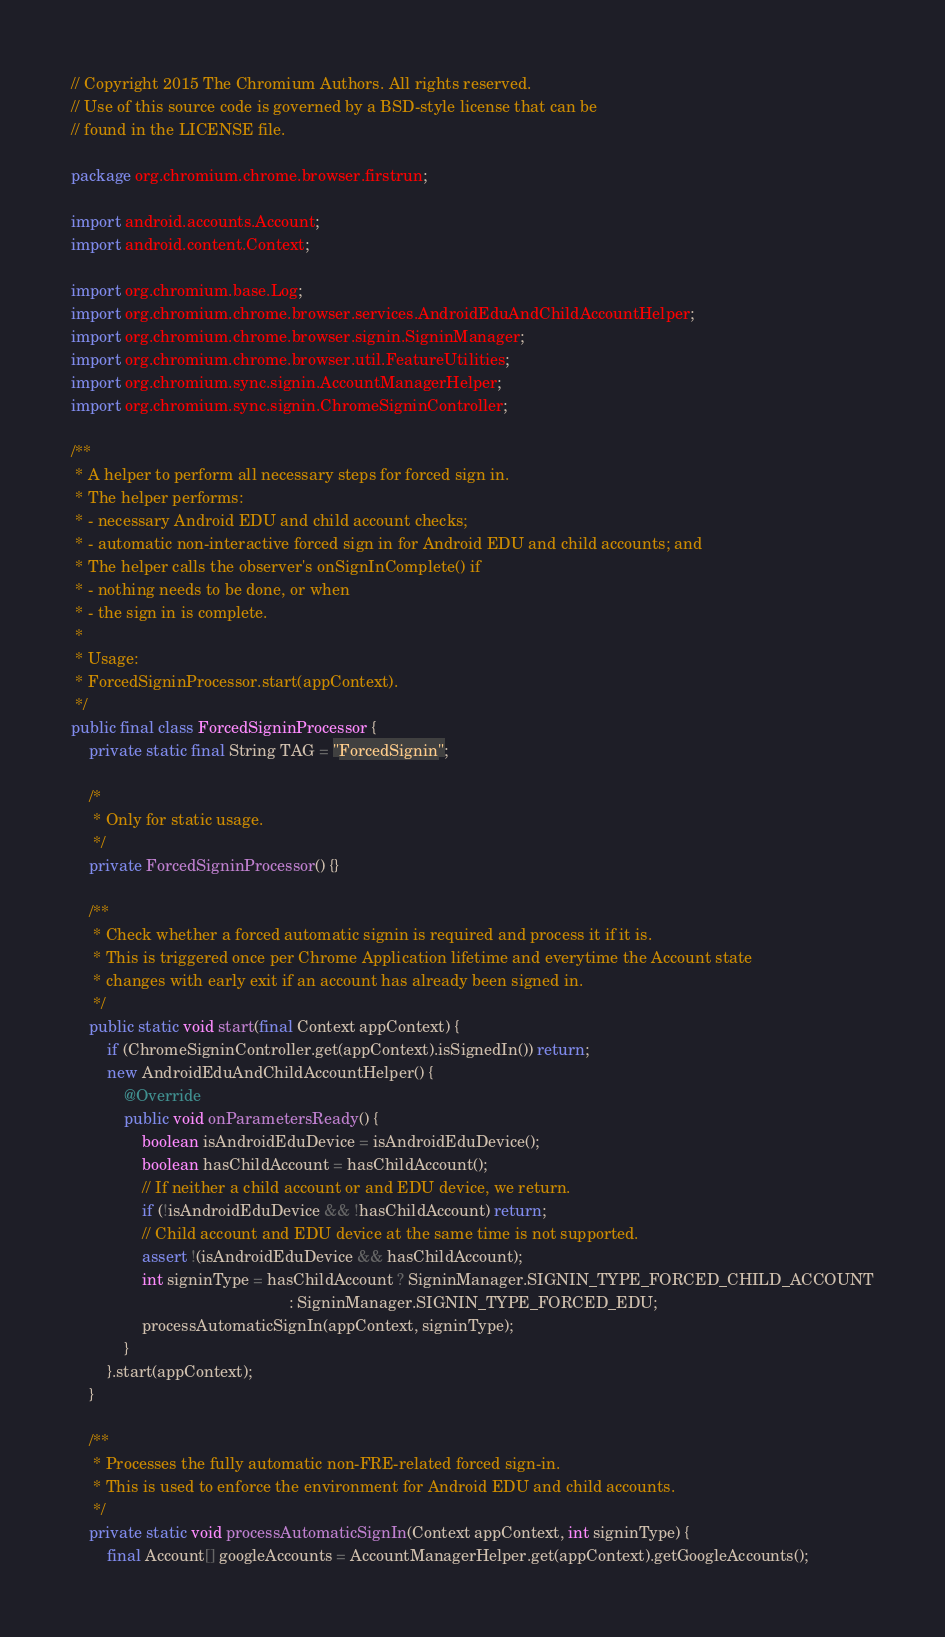Convert code to text. <code><loc_0><loc_0><loc_500><loc_500><_Java_>// Copyright 2015 The Chromium Authors. All rights reserved.
// Use of this source code is governed by a BSD-style license that can be
// found in the LICENSE file.

package org.chromium.chrome.browser.firstrun;

import android.accounts.Account;
import android.content.Context;

import org.chromium.base.Log;
import org.chromium.chrome.browser.services.AndroidEduAndChildAccountHelper;
import org.chromium.chrome.browser.signin.SigninManager;
import org.chromium.chrome.browser.util.FeatureUtilities;
import org.chromium.sync.signin.AccountManagerHelper;
import org.chromium.sync.signin.ChromeSigninController;

/**
 * A helper to perform all necessary steps for forced sign in.
 * The helper performs:
 * - necessary Android EDU and child account checks;
 * - automatic non-interactive forced sign in for Android EDU and child accounts; and
 * The helper calls the observer's onSignInComplete() if
 * - nothing needs to be done, or when
 * - the sign in is complete.
 *
 * Usage:
 * ForcedSigninProcessor.start(appContext).
 */
public final class ForcedSigninProcessor {
    private static final String TAG = "ForcedSignin";

    /*
     * Only for static usage.
     */
    private ForcedSigninProcessor() {}

    /**
     * Check whether a forced automatic signin is required and process it if it is.
     * This is triggered once per Chrome Application lifetime and everytime the Account state
     * changes with early exit if an account has already been signed in.
     */
    public static void start(final Context appContext) {
        if (ChromeSigninController.get(appContext).isSignedIn()) return;
        new AndroidEduAndChildAccountHelper() {
            @Override
            public void onParametersReady() {
                boolean isAndroidEduDevice = isAndroidEduDevice();
                boolean hasChildAccount = hasChildAccount();
                // If neither a child account or and EDU device, we return.
                if (!isAndroidEduDevice && !hasChildAccount) return;
                // Child account and EDU device at the same time is not supported.
                assert !(isAndroidEduDevice && hasChildAccount);
                int signinType = hasChildAccount ? SigninManager.SIGNIN_TYPE_FORCED_CHILD_ACCOUNT
                                                 : SigninManager.SIGNIN_TYPE_FORCED_EDU;
                processAutomaticSignIn(appContext, signinType);
            }
        }.start(appContext);
    }

    /**
     * Processes the fully automatic non-FRE-related forced sign-in.
     * This is used to enforce the environment for Android EDU and child accounts.
     */
    private static void processAutomaticSignIn(Context appContext, int signinType) {
        final Account[] googleAccounts = AccountManagerHelper.get(appContext).getGoogleAccounts();</code> 